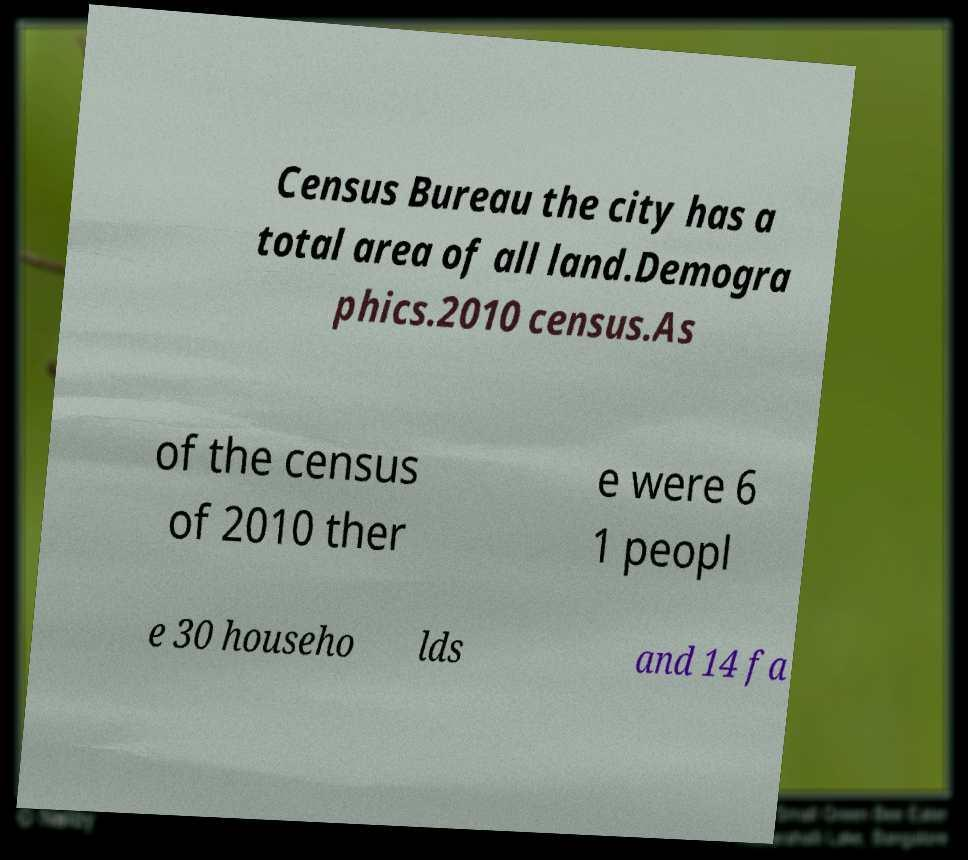What messages or text are displayed in this image? I need them in a readable, typed format. Census Bureau the city has a total area of all land.Demogra phics.2010 census.As of the census of 2010 ther e were 6 1 peopl e 30 househo lds and 14 fa 